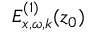Convert formula to latex. <formula><loc_0><loc_0><loc_500><loc_500>E _ { x , \omega , k } ^ { ( 1 ) } ( z _ { 0 } )</formula> 